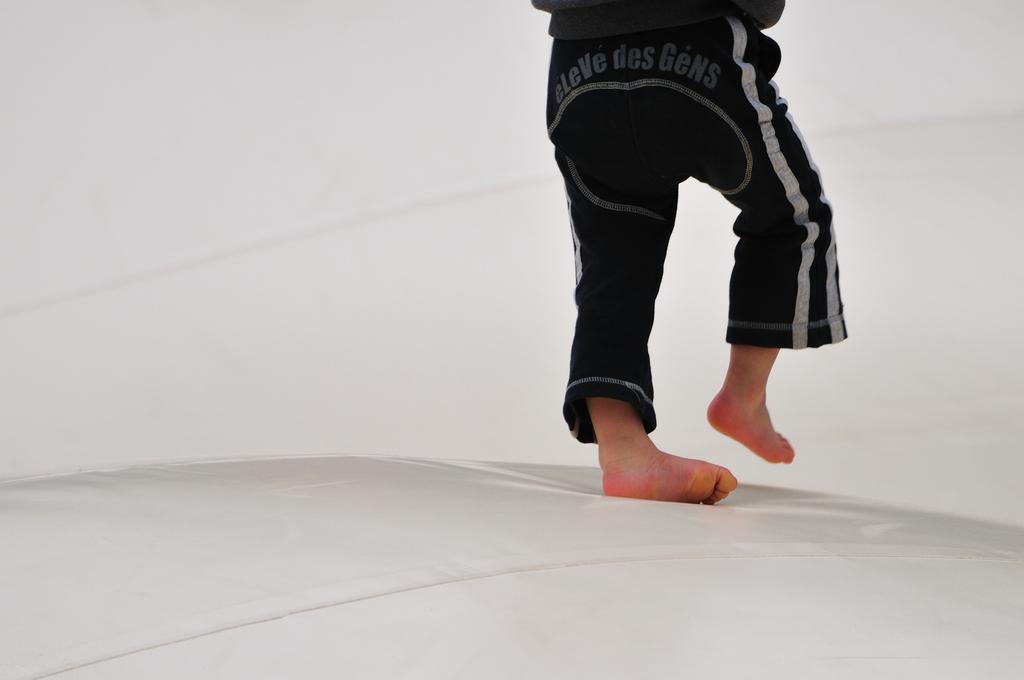How would you summarize this image in a sentence or two? Here I can see a person wearing black color dress and walking on a white surface. The background is in white color. 